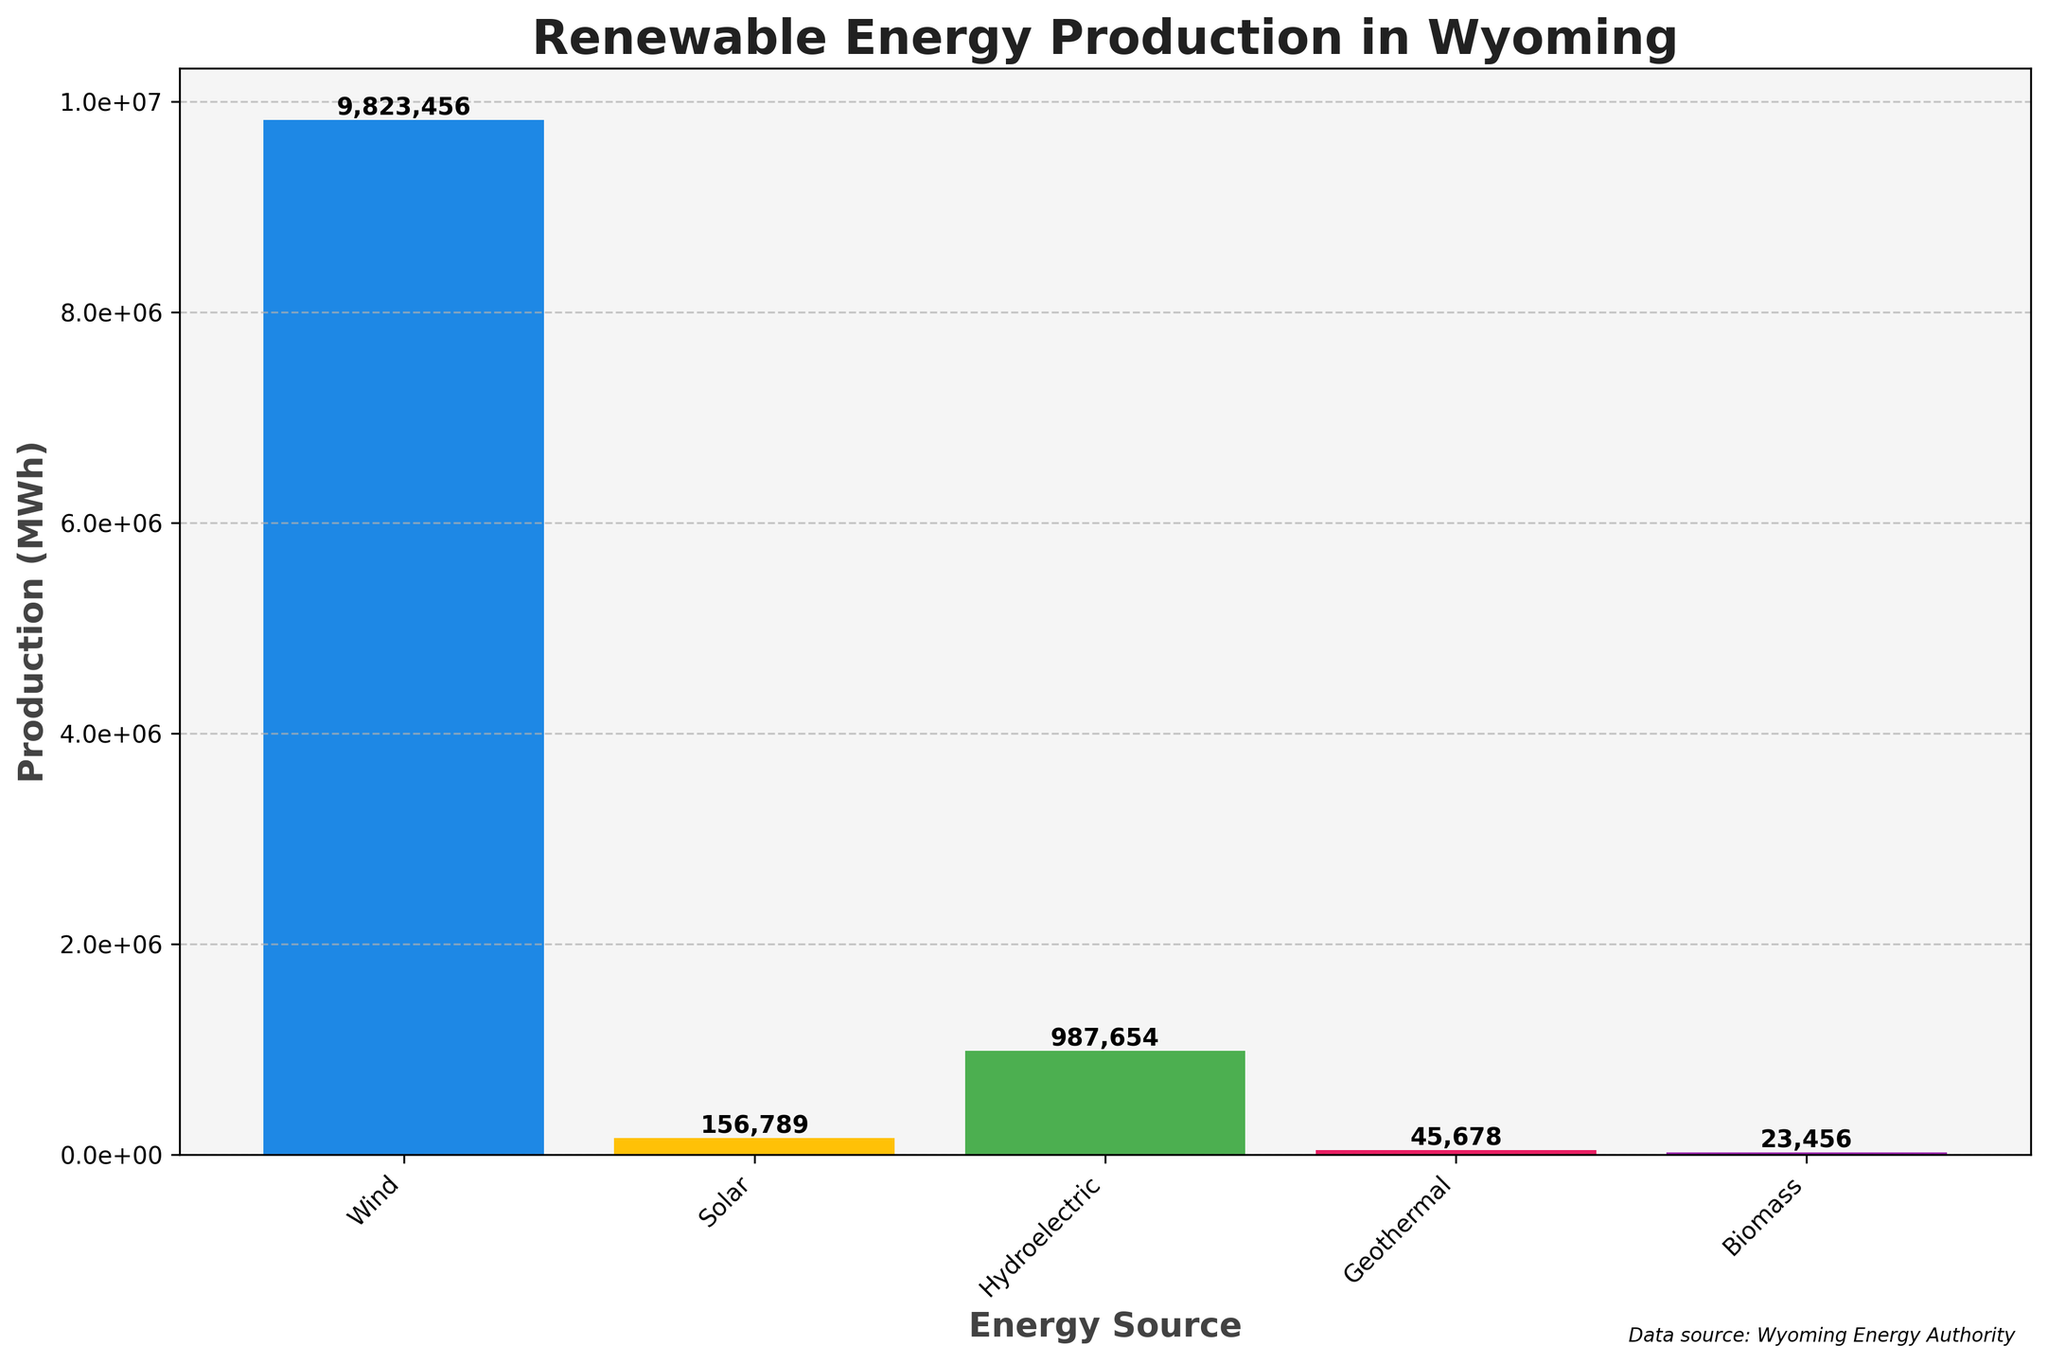What is the highest renewable energy production source in Wyoming? The tallest bar in the figure represents the energy source with the highest production. Here, the wind energy bar is the tallest.
Answer: Wind What is the second highest renewable energy production source in Wyoming? The second tallest bar in the figure represents the second highest production. The hydroelectric energy bar is the second tallest.
Answer: Hydroelectric How much more energy does wind produce compared to solar? The production for wind is 9,823,456 MWh, and for solar, it is 156,789 MWh. Subtracting the solar production from the wind production gives 9,823,456 - 156,789 = 9,666,667 MWh.
Answer: 9,666,667 What is the total renewable energy production in Wyoming? Summing up the production of all energy sources: 9,823,456 (Wind) + 156,789 (Solar) + 987,654 (Hydroelectric) + 45,678 (Geothermal) + 23,456 (Biomass) = 11,036,033 MWh.
Answer: 11,036,033 Which energy source produces the least amount of energy? The shortest bar in the figure indicates the energy source with the lowest production. The biomass energy bar is the shortest.
Answer: Biomass How does the height of the biomass bar compare to the geothermal bar? The geothermal energy bar is taller than the biomass energy bar, indicating higher production.
Answer: Geothermal is higher How many energy sources produce less than 1,000,000 MWh? By identifying bars shorter than the 1,000,000 MWh mark: solar (156,789), geothermal (45,678), and biomass (23,456) meet this criterion. That's three energy sources.
Answer: 3 What is the difference between hydroelectric and geothermal energy production? The hydroelectric production is 987,654 MWh and the geothermal production is 45,678 MWh. The difference is 987,654 - 45,678 = 941,976 MWh.
Answer: 941,976 What is the average production of solar and biomass energy? Summing solar and biomass production: 156,789 (Solar) + 23,456 (Biomass) = 180,245 MWh. The average is 180,245 / 2 = 90,122.5 MWh.
Answer: 90,122.5 What color is the bar representing biomass energy? The color of the biomass energy bar needs to be identified visually. It is purple in the figure.
Answer: Purple 